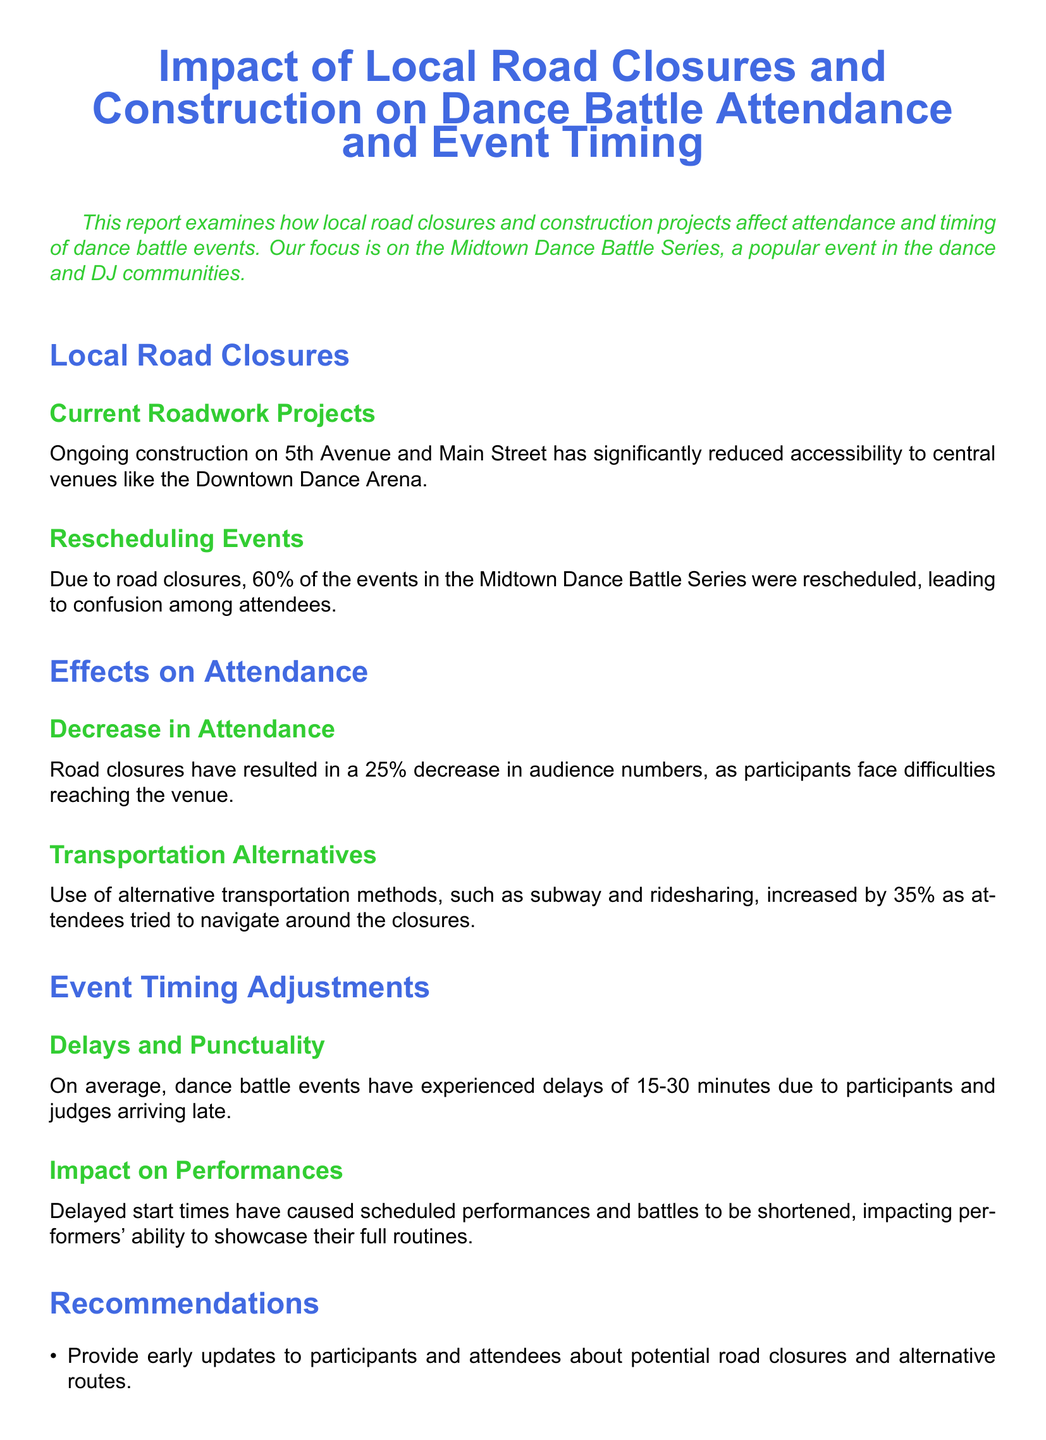What is the percentage decrease in attendance? The report states that there has been a 25% decrease in audience numbers due to road closures.
Answer: 25% How many events were rescheduled due to road closures? The document mentions that 60% of the events in the Midtown Dance Battle Series were rescheduled.
Answer: 60% What are the two main affected streets mentioned in the report? The streets impacted by construction are 5th Avenue and Main Street.
Answer: 5th Avenue and Main Street What is the average delay in dance battle events? The reported average delay for events is between 15-30 minutes.
Answer: 15-30 minutes What increase in alternative transportation usage was noted? It was noted that the use of alternate transportation methods increased by 35%.
Answer: 35% Which venue is significantly affected by the road closures? The document points out that the Downtown Dance Arena has significantly reduced accessibility due to road closures.
Answer: Downtown Dance Arena What technology-related recommendation is suggested for attendees? The report suggests implementing mobile apps to provide real-time traffic updates for attendees.
Answer: Mobile apps What type of events are primarily affected by the local road closures? The events primarily affected are the dance battles, specifically the Midtown Dance Battle Series.
Answer: Dance battles 